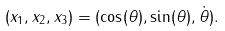Convert formula to latex. <formula><loc_0><loc_0><loc_500><loc_500>( x _ { 1 } , x _ { 2 } , x _ { 3 } ) = ( \cos ( \theta ) , \sin ( \theta ) , \dot { \theta } ) .</formula> 